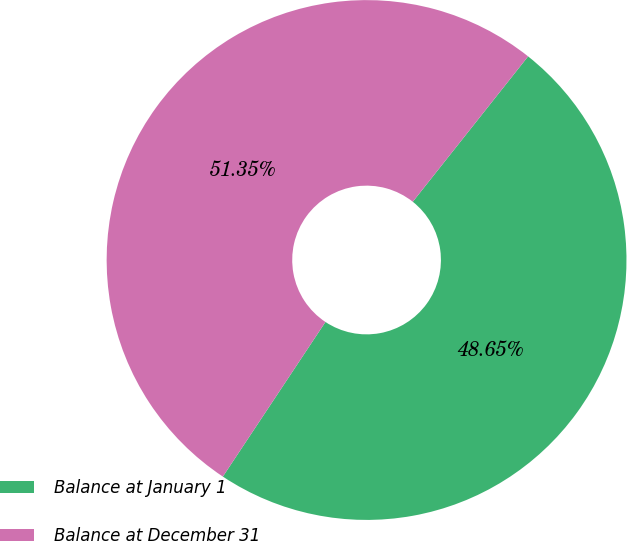Convert chart. <chart><loc_0><loc_0><loc_500><loc_500><pie_chart><fcel>Balance at January 1<fcel>Balance at December 31<nl><fcel>48.65%<fcel>51.35%<nl></chart> 